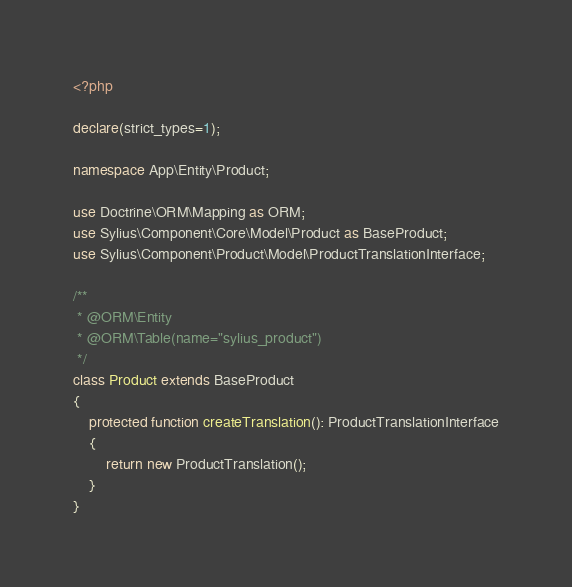<code> <loc_0><loc_0><loc_500><loc_500><_PHP_><?php

declare(strict_types=1);

namespace App\Entity\Product;

use Doctrine\ORM\Mapping as ORM;
use Sylius\Component\Core\Model\Product as BaseProduct;
use Sylius\Component\Product\Model\ProductTranslationInterface;

/**
 * @ORM\Entity
 * @ORM\Table(name="sylius_product")
 */
class Product extends BaseProduct
{
    protected function createTranslation(): ProductTranslationInterface
    {
        return new ProductTranslation();
    }
}
</code> 